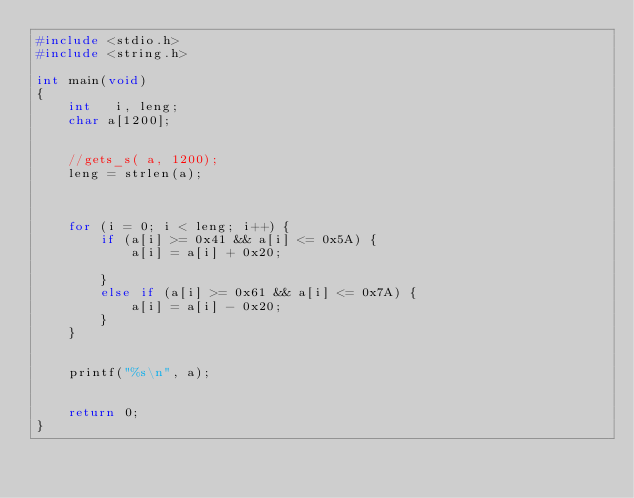Convert code to text. <code><loc_0><loc_0><loc_500><loc_500><_C_>#include <stdio.h>
#include <string.h>

int main(void)
{
	int   i, leng;
	char a[1200];


	//gets_s( a, 1200);
	leng = strlen(a);

	

	for (i = 0; i < leng; i++) {
		if (a[i] >= 0x41 && a[i] <= 0x5A) {
			a[i] = a[i] + 0x20;
			
		}
		else if (a[i] >= 0x61 && a[i] <= 0x7A) {
			a[i] = a[i] - 0x20;
		}
	}


	printf("%s\n", a);

	
	return 0;
}
</code> 